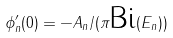Convert formula to latex. <formula><loc_0><loc_0><loc_500><loc_500>\phi _ { n } ^ { \prime } ( 0 ) = - A _ { n } / ( \pi \text {Bi} ( E _ { n } ) )</formula> 